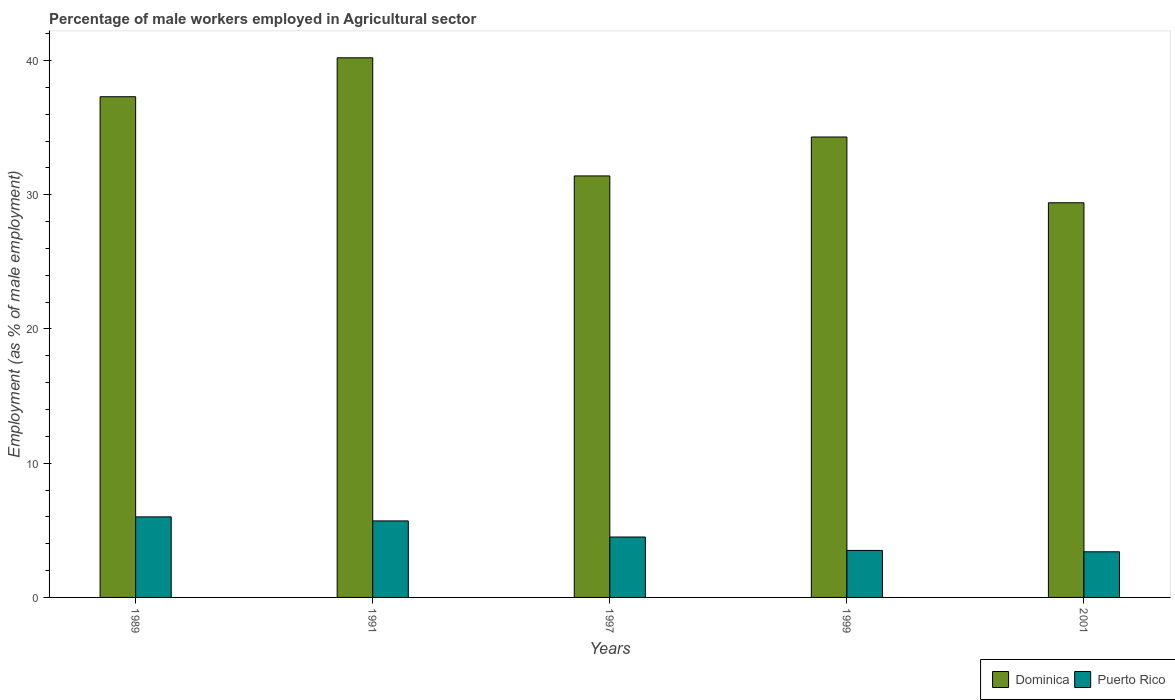How many groups of bars are there?
Provide a succinct answer. 5. Are the number of bars per tick equal to the number of legend labels?
Provide a succinct answer. Yes. What is the label of the 1st group of bars from the left?
Your response must be concise. 1989. What is the percentage of male workers employed in Agricultural sector in Puerto Rico in 2001?
Offer a very short reply. 3.4. Across all years, what is the maximum percentage of male workers employed in Agricultural sector in Dominica?
Ensure brevity in your answer.  40.2. Across all years, what is the minimum percentage of male workers employed in Agricultural sector in Puerto Rico?
Offer a terse response. 3.4. What is the total percentage of male workers employed in Agricultural sector in Dominica in the graph?
Offer a terse response. 172.6. What is the difference between the percentage of male workers employed in Agricultural sector in Dominica in 1989 and that in 2001?
Make the answer very short. 7.9. What is the difference between the percentage of male workers employed in Agricultural sector in Puerto Rico in 1997 and the percentage of male workers employed in Agricultural sector in Dominica in 1989?
Offer a terse response. -32.8. What is the average percentage of male workers employed in Agricultural sector in Puerto Rico per year?
Your answer should be very brief. 4.62. In the year 1991, what is the difference between the percentage of male workers employed in Agricultural sector in Dominica and percentage of male workers employed in Agricultural sector in Puerto Rico?
Provide a succinct answer. 34.5. What is the ratio of the percentage of male workers employed in Agricultural sector in Puerto Rico in 1989 to that in 1997?
Make the answer very short. 1.33. Is the percentage of male workers employed in Agricultural sector in Puerto Rico in 1989 less than that in 1991?
Make the answer very short. No. What is the difference between the highest and the second highest percentage of male workers employed in Agricultural sector in Puerto Rico?
Keep it short and to the point. 0.3. What is the difference between the highest and the lowest percentage of male workers employed in Agricultural sector in Dominica?
Provide a succinct answer. 10.8. Is the sum of the percentage of male workers employed in Agricultural sector in Dominica in 1997 and 1999 greater than the maximum percentage of male workers employed in Agricultural sector in Puerto Rico across all years?
Provide a short and direct response. Yes. What does the 1st bar from the left in 1989 represents?
Your answer should be very brief. Dominica. What does the 1st bar from the right in 1991 represents?
Your answer should be compact. Puerto Rico. Are the values on the major ticks of Y-axis written in scientific E-notation?
Give a very brief answer. No. Where does the legend appear in the graph?
Give a very brief answer. Bottom right. How many legend labels are there?
Your response must be concise. 2. What is the title of the graph?
Ensure brevity in your answer.  Percentage of male workers employed in Agricultural sector. Does "Venezuela" appear as one of the legend labels in the graph?
Provide a short and direct response. No. What is the label or title of the X-axis?
Your answer should be compact. Years. What is the label or title of the Y-axis?
Your answer should be compact. Employment (as % of male employment). What is the Employment (as % of male employment) of Dominica in 1989?
Provide a short and direct response. 37.3. What is the Employment (as % of male employment) in Dominica in 1991?
Ensure brevity in your answer.  40.2. What is the Employment (as % of male employment) in Puerto Rico in 1991?
Your response must be concise. 5.7. What is the Employment (as % of male employment) of Dominica in 1997?
Give a very brief answer. 31.4. What is the Employment (as % of male employment) in Dominica in 1999?
Ensure brevity in your answer.  34.3. What is the Employment (as % of male employment) in Puerto Rico in 1999?
Your answer should be very brief. 3.5. What is the Employment (as % of male employment) in Dominica in 2001?
Your response must be concise. 29.4. What is the Employment (as % of male employment) in Puerto Rico in 2001?
Provide a short and direct response. 3.4. Across all years, what is the maximum Employment (as % of male employment) in Dominica?
Provide a short and direct response. 40.2. Across all years, what is the minimum Employment (as % of male employment) in Dominica?
Offer a terse response. 29.4. Across all years, what is the minimum Employment (as % of male employment) in Puerto Rico?
Your answer should be very brief. 3.4. What is the total Employment (as % of male employment) in Dominica in the graph?
Offer a terse response. 172.6. What is the total Employment (as % of male employment) in Puerto Rico in the graph?
Make the answer very short. 23.1. What is the difference between the Employment (as % of male employment) of Dominica in 1989 and that in 1991?
Provide a succinct answer. -2.9. What is the difference between the Employment (as % of male employment) in Dominica in 1989 and that in 1997?
Your response must be concise. 5.9. What is the difference between the Employment (as % of male employment) in Dominica in 1989 and that in 1999?
Ensure brevity in your answer.  3. What is the difference between the Employment (as % of male employment) in Dominica in 1989 and that in 2001?
Offer a very short reply. 7.9. What is the difference between the Employment (as % of male employment) in Puerto Rico in 1991 and that in 2001?
Give a very brief answer. 2.3. What is the difference between the Employment (as % of male employment) in Dominica in 1997 and that in 1999?
Ensure brevity in your answer.  -2.9. What is the difference between the Employment (as % of male employment) in Dominica in 1997 and that in 2001?
Keep it short and to the point. 2. What is the difference between the Employment (as % of male employment) in Puerto Rico in 1999 and that in 2001?
Keep it short and to the point. 0.1. What is the difference between the Employment (as % of male employment) of Dominica in 1989 and the Employment (as % of male employment) of Puerto Rico in 1991?
Offer a terse response. 31.6. What is the difference between the Employment (as % of male employment) of Dominica in 1989 and the Employment (as % of male employment) of Puerto Rico in 1997?
Your response must be concise. 32.8. What is the difference between the Employment (as % of male employment) in Dominica in 1989 and the Employment (as % of male employment) in Puerto Rico in 1999?
Provide a succinct answer. 33.8. What is the difference between the Employment (as % of male employment) of Dominica in 1989 and the Employment (as % of male employment) of Puerto Rico in 2001?
Your answer should be very brief. 33.9. What is the difference between the Employment (as % of male employment) in Dominica in 1991 and the Employment (as % of male employment) in Puerto Rico in 1997?
Your response must be concise. 35.7. What is the difference between the Employment (as % of male employment) of Dominica in 1991 and the Employment (as % of male employment) of Puerto Rico in 1999?
Make the answer very short. 36.7. What is the difference between the Employment (as % of male employment) in Dominica in 1991 and the Employment (as % of male employment) in Puerto Rico in 2001?
Your response must be concise. 36.8. What is the difference between the Employment (as % of male employment) of Dominica in 1997 and the Employment (as % of male employment) of Puerto Rico in 1999?
Offer a terse response. 27.9. What is the difference between the Employment (as % of male employment) of Dominica in 1999 and the Employment (as % of male employment) of Puerto Rico in 2001?
Give a very brief answer. 30.9. What is the average Employment (as % of male employment) of Dominica per year?
Ensure brevity in your answer.  34.52. What is the average Employment (as % of male employment) in Puerto Rico per year?
Provide a short and direct response. 4.62. In the year 1989, what is the difference between the Employment (as % of male employment) in Dominica and Employment (as % of male employment) in Puerto Rico?
Offer a terse response. 31.3. In the year 1991, what is the difference between the Employment (as % of male employment) in Dominica and Employment (as % of male employment) in Puerto Rico?
Your answer should be very brief. 34.5. In the year 1997, what is the difference between the Employment (as % of male employment) in Dominica and Employment (as % of male employment) in Puerto Rico?
Provide a short and direct response. 26.9. In the year 1999, what is the difference between the Employment (as % of male employment) in Dominica and Employment (as % of male employment) in Puerto Rico?
Give a very brief answer. 30.8. What is the ratio of the Employment (as % of male employment) of Dominica in 1989 to that in 1991?
Your answer should be compact. 0.93. What is the ratio of the Employment (as % of male employment) in Puerto Rico in 1989 to that in 1991?
Offer a terse response. 1.05. What is the ratio of the Employment (as % of male employment) of Dominica in 1989 to that in 1997?
Provide a short and direct response. 1.19. What is the ratio of the Employment (as % of male employment) of Dominica in 1989 to that in 1999?
Ensure brevity in your answer.  1.09. What is the ratio of the Employment (as % of male employment) in Puerto Rico in 1989 to that in 1999?
Give a very brief answer. 1.71. What is the ratio of the Employment (as % of male employment) in Dominica in 1989 to that in 2001?
Offer a terse response. 1.27. What is the ratio of the Employment (as % of male employment) in Puerto Rico in 1989 to that in 2001?
Ensure brevity in your answer.  1.76. What is the ratio of the Employment (as % of male employment) of Dominica in 1991 to that in 1997?
Offer a very short reply. 1.28. What is the ratio of the Employment (as % of male employment) of Puerto Rico in 1991 to that in 1997?
Your answer should be compact. 1.27. What is the ratio of the Employment (as % of male employment) of Dominica in 1991 to that in 1999?
Offer a terse response. 1.17. What is the ratio of the Employment (as % of male employment) in Puerto Rico in 1991 to that in 1999?
Provide a succinct answer. 1.63. What is the ratio of the Employment (as % of male employment) in Dominica in 1991 to that in 2001?
Your answer should be compact. 1.37. What is the ratio of the Employment (as % of male employment) of Puerto Rico in 1991 to that in 2001?
Offer a terse response. 1.68. What is the ratio of the Employment (as % of male employment) in Dominica in 1997 to that in 1999?
Your answer should be compact. 0.92. What is the ratio of the Employment (as % of male employment) in Dominica in 1997 to that in 2001?
Make the answer very short. 1.07. What is the ratio of the Employment (as % of male employment) of Puerto Rico in 1997 to that in 2001?
Provide a succinct answer. 1.32. What is the ratio of the Employment (as % of male employment) of Puerto Rico in 1999 to that in 2001?
Provide a short and direct response. 1.03. What is the difference between the highest and the lowest Employment (as % of male employment) in Dominica?
Provide a short and direct response. 10.8. 